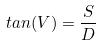<formula> <loc_0><loc_0><loc_500><loc_500>t a n ( V ) = \frac { S } { D }</formula> 